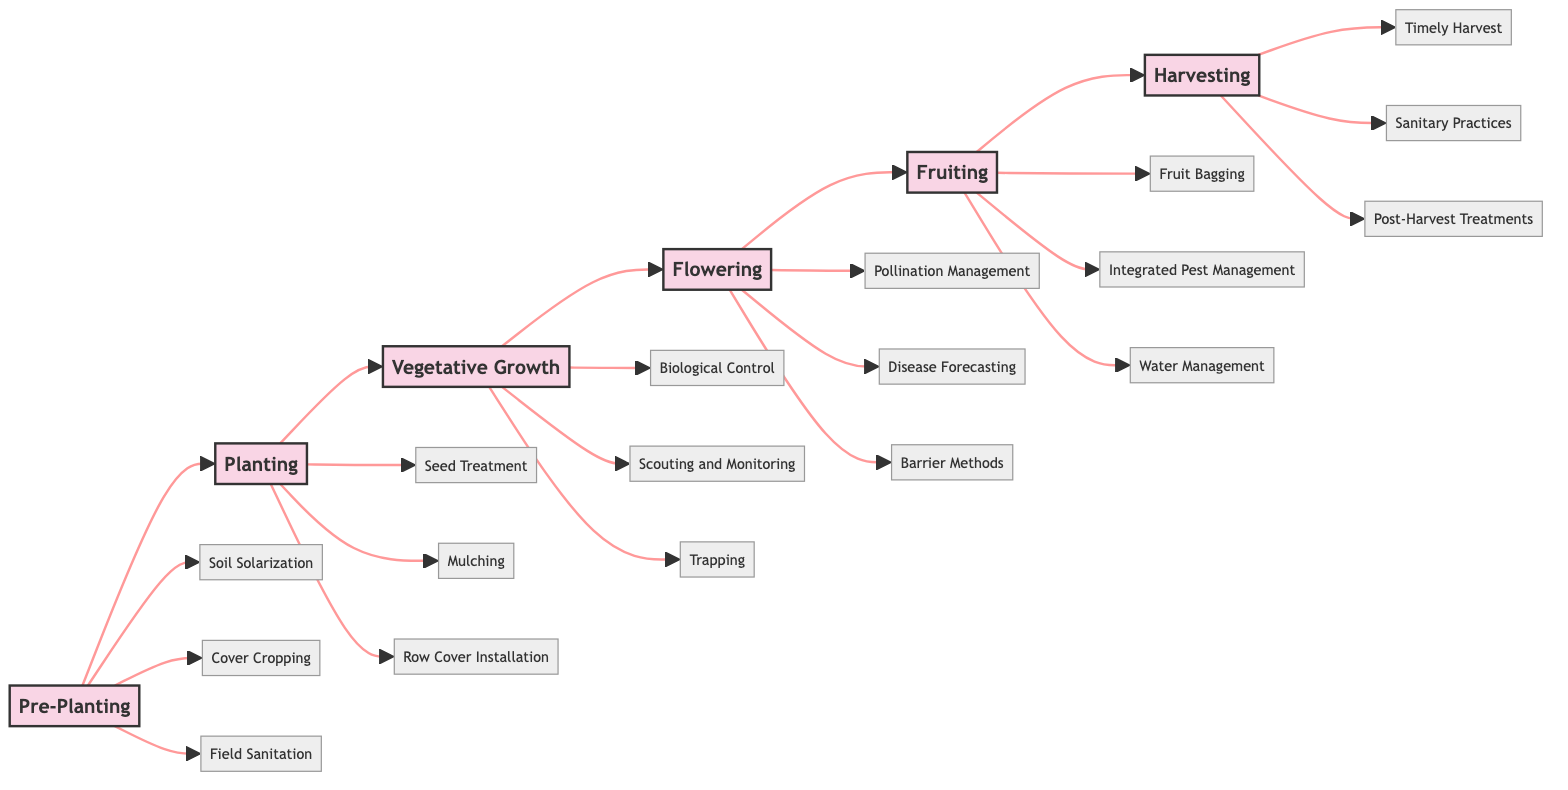What's the first stage in the Seasonal Crop Protection Plan? The diagram shows that the first stage is labeled as "Pre-Planting". It is the starting node in the flowchart and moves to the next stage, "Planting".
Answer: Pre-Planting How many deterrent measures are listed for the Fruiting stage? By inspecting the Fruiting stage node, it shows three measures connected to it: "Fruit Bagging", "Integrated Pest Management", and "Water Management". Thus, there are three measures in total for this stage.
Answer: 3 What measure is associated with the Vegetative Growth stage that involves monitoring? The diagram lists "Scouting and Monitoring" as one of the measures connected to the Vegetative Growth stage, indicating it is the relevant monitoring measure.
Answer: Scouting and Monitoring Which two stages are directly linked in a row? The flowchart indicates a direct path from "Pre-Planting" to "Planting", as well as from "Planting" to "Vegetative Growth". Thus, the two stages that are linked directly in a row can be "Pre-Planting" and "Planting".
Answer: Pre-Planting and Planting Which measure is focused on protecting plants from pests during the Planting stage? In the Planting stage, the diagram indicates "Row Cover Installation" as a measure specifically intended to protect young plants from pests.
Answer: Row Cover Installation How many total stages are there in the Seasonal Crop Protection Plan? The flowchart features six distinct stages: "Pre-Planting", "Planting", "Vegetative Growth", "Flowering", "Fruiting", and "Harvesting". Therefore, the total number of stages is six.
Answer: 6 What is the final measure listed at the Harvesting stage? The flowchart shows "Post-Harvest Treatments" as the last measure connected to the Harvesting stage, indicating it is the final measure.
Answer: Post-Harvest Treatments Which measure at the Flowering stage relates to disease prediction? The diagram specifies "Disease Forecasting" as a measure linked to the Flowering stage, which pertains to utilizing weather data to predict disease outbreaks.
Answer: Disease Forecasting 